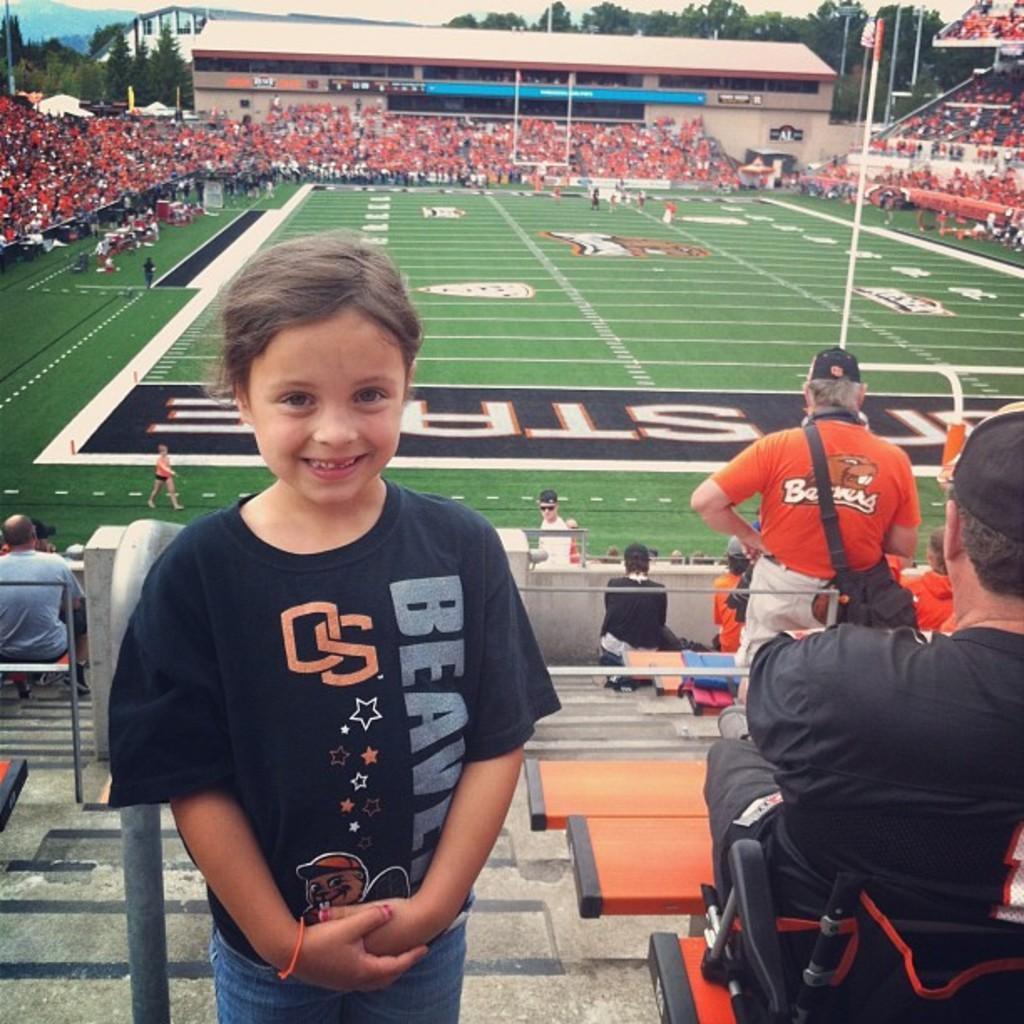Can you describe this image briefly? In the image we can see there is a kid standing and there are other people sitting on the chair. There is a ground covered with grass and there are other people standing on the ground. There are spectators sitting on the chair and there are buildings and there are trees. 